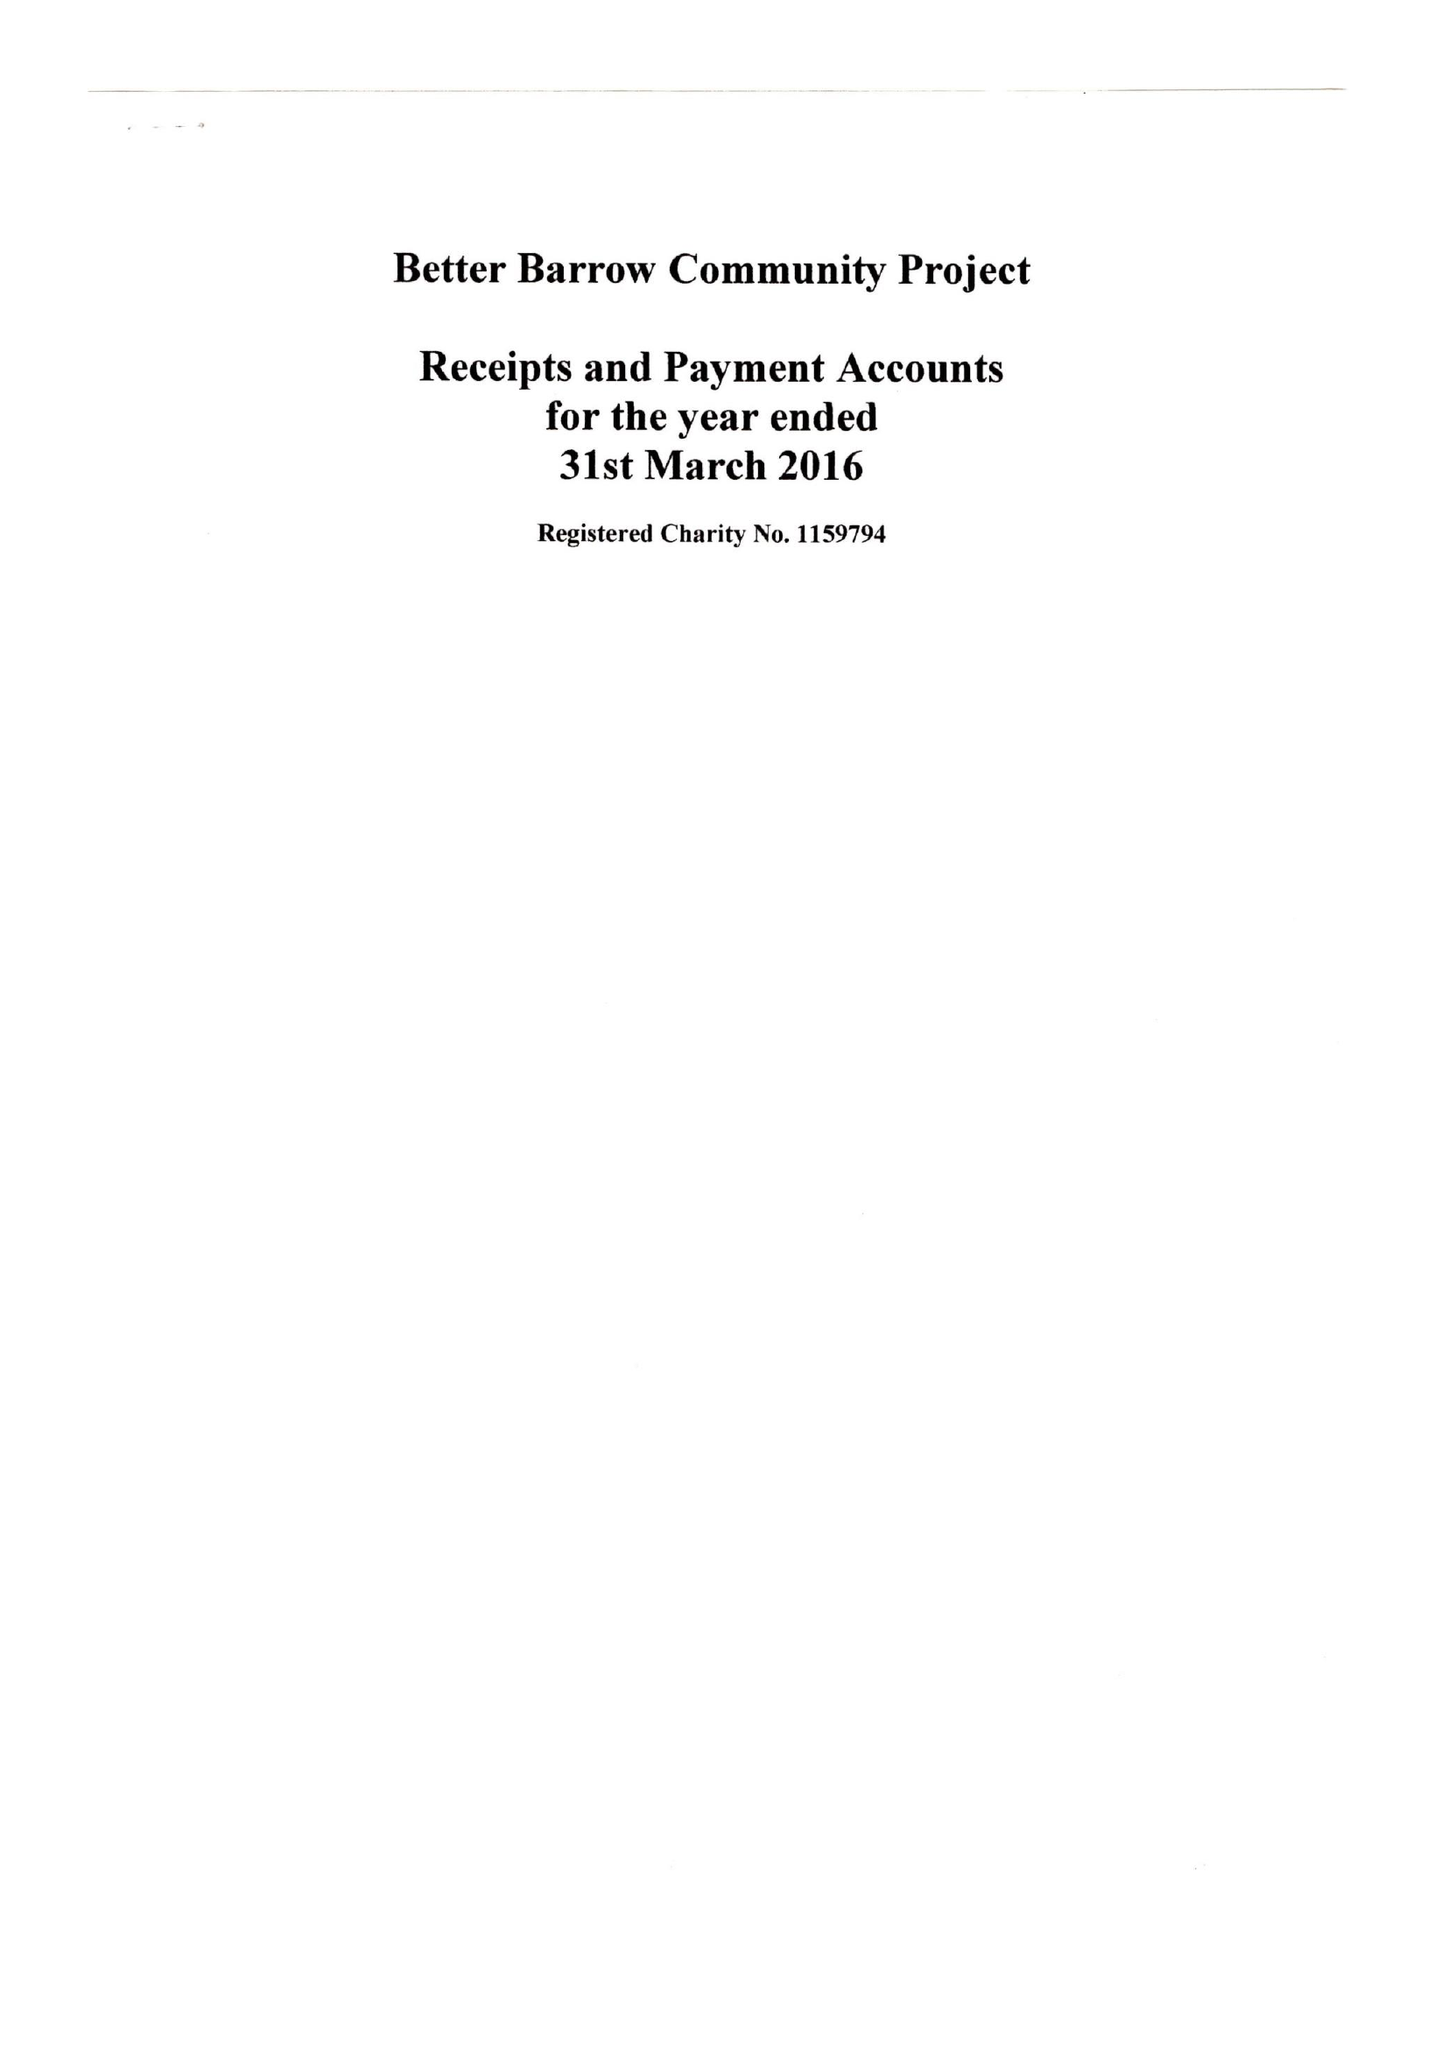What is the value for the charity_number?
Answer the question using a single word or phrase. 1159794 